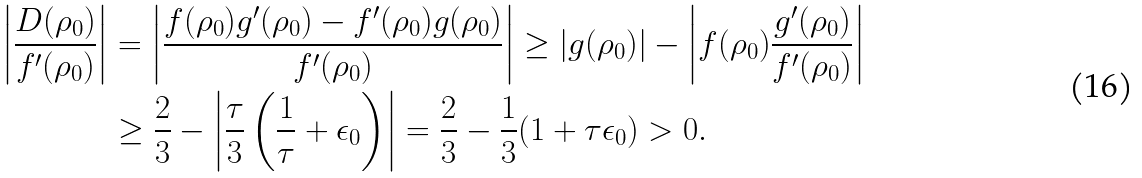<formula> <loc_0><loc_0><loc_500><loc_500>\left | \frac { D ( \rho _ { 0 } ) } { f ^ { \prime } ( \rho _ { 0 } ) } \right | & = \left | \frac { f ( \rho _ { 0 } ) g ^ { \prime } ( \rho _ { 0 } ) - f ^ { \prime } ( \rho _ { 0 } ) g ( \rho _ { 0 } ) } { f ^ { \prime } ( \rho _ { 0 } ) } \right | \geq | g ( \rho _ { 0 } ) | - \left | f ( \rho _ { 0 } ) \frac { g ^ { \prime } ( \rho _ { 0 } ) } { f ^ { \prime } ( \rho _ { 0 } ) } \right | \\ & \geq \frac { 2 } { 3 } - \left | \frac { \tau } { 3 } \left ( \frac { 1 } { \tau } + \epsilon _ { 0 } \right ) \right | = \frac { 2 } { 3 } - \frac { 1 } { 3 } ( 1 + \tau \epsilon _ { 0 } ) > 0 .</formula> 